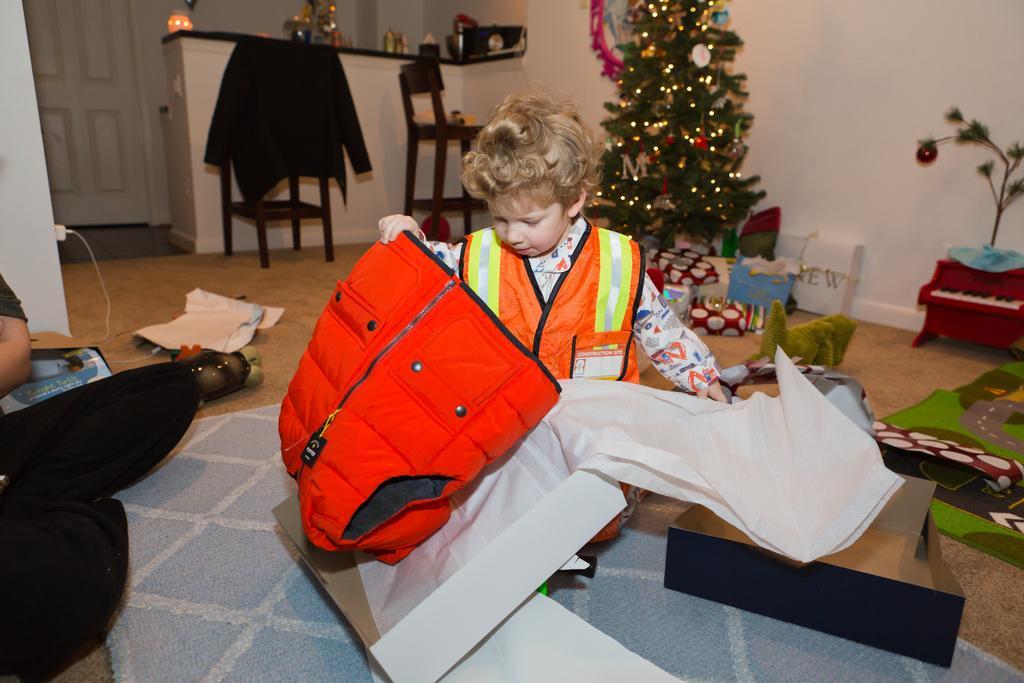In one or two sentences, can you explain what this image depicts? This is the picture of a boy wearing a safety dress and holding are red jacket. Behind the boy there is a Christmas tree, chair and a wall. 